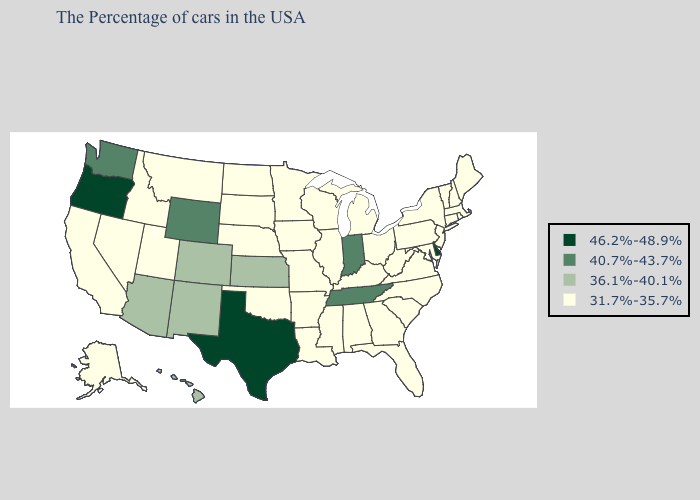How many symbols are there in the legend?
Give a very brief answer. 4. What is the highest value in the South ?
Quick response, please. 46.2%-48.9%. What is the lowest value in the USA?
Give a very brief answer. 31.7%-35.7%. Which states have the lowest value in the Northeast?
Short answer required. Maine, Massachusetts, Rhode Island, New Hampshire, Vermont, Connecticut, New York, New Jersey, Pennsylvania. Does Tennessee have the lowest value in the USA?
Be succinct. No. What is the value of Oklahoma?
Concise answer only. 31.7%-35.7%. Among the states that border Kansas , which have the lowest value?
Write a very short answer. Missouri, Nebraska, Oklahoma. What is the value of Rhode Island?
Be succinct. 31.7%-35.7%. How many symbols are there in the legend?
Quick response, please. 4. What is the value of Wyoming?
Write a very short answer. 40.7%-43.7%. What is the value of Connecticut?
Answer briefly. 31.7%-35.7%. Name the states that have a value in the range 46.2%-48.9%?
Short answer required. Delaware, Texas, Oregon. Does Massachusetts have the highest value in the USA?
Write a very short answer. No. Does Michigan have the same value as Oklahoma?
Answer briefly. Yes. What is the value of New Jersey?
Give a very brief answer. 31.7%-35.7%. 